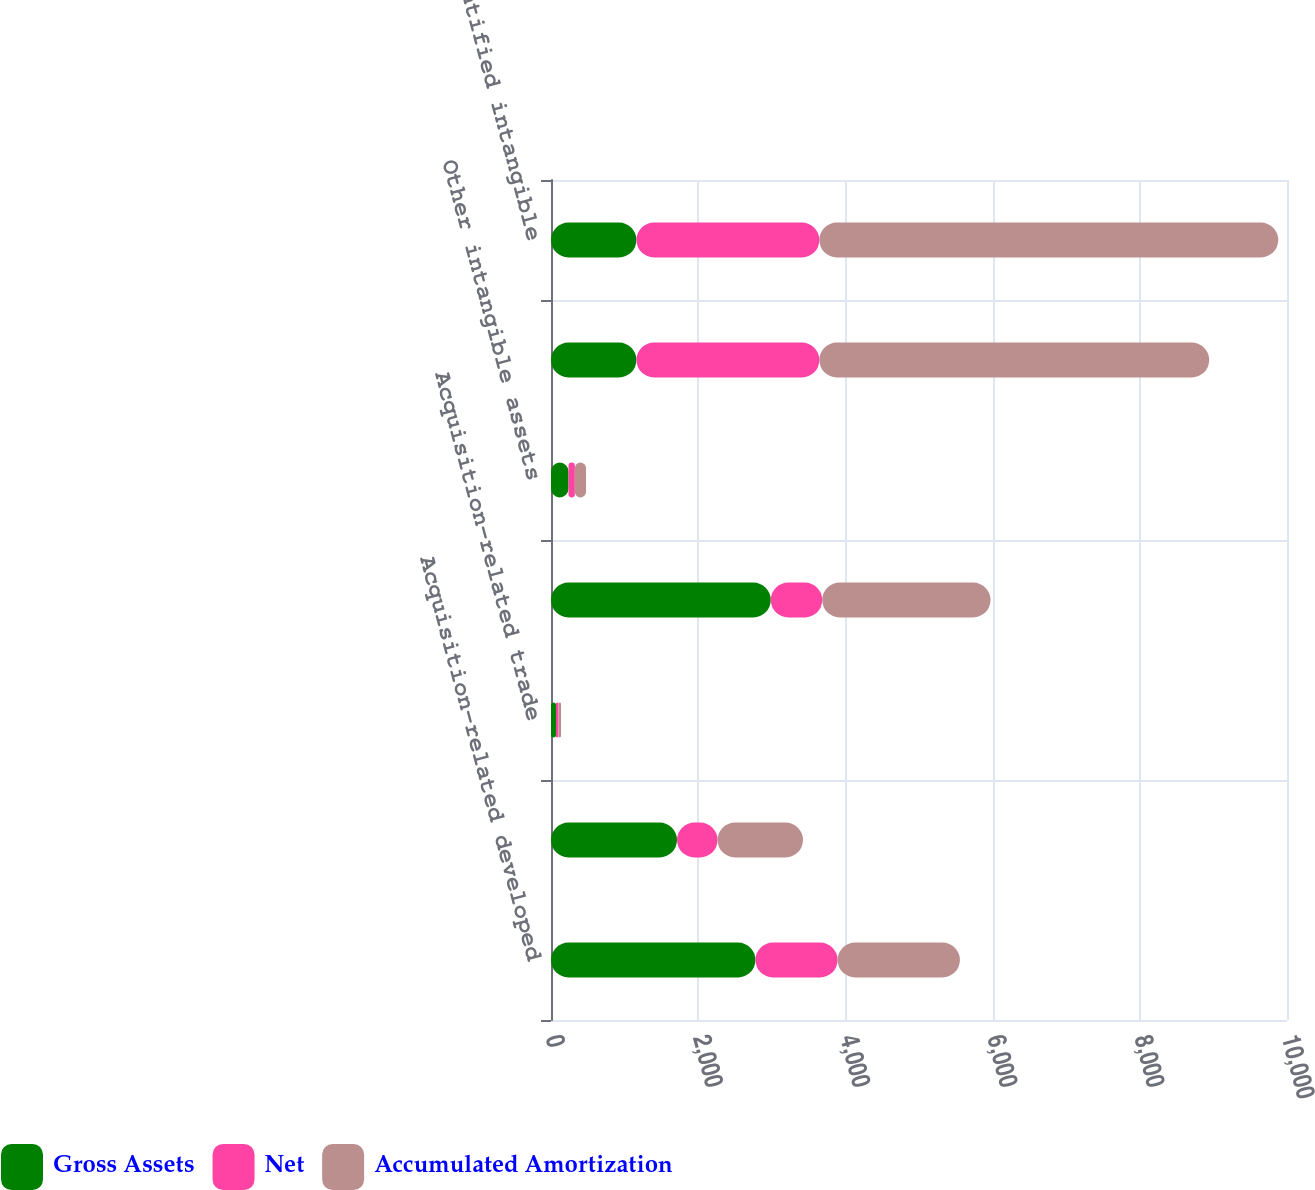Convert chart to OTSL. <chart><loc_0><loc_0><loc_500><loc_500><stacked_bar_chart><ecel><fcel>Acquisition-related developed<fcel>Acquisition-related customer<fcel>Acquisition-related trade<fcel>Licensed technology and<fcel>Other intangible assets<fcel>Identified intangible assets<fcel>Total identified intangible<nl><fcel>Gross Assets<fcel>2778<fcel>1712<fcel>68<fcel>2986<fcel>238<fcel>1161<fcel>1161<nl><fcel>Net<fcel>1116<fcel>551<fcel>33<fcel>699<fcel>86<fcel>2485<fcel>2485<nl><fcel>Accumulated Amortization<fcel>1662<fcel>1161<fcel>35<fcel>2287<fcel>152<fcel>5297<fcel>6235<nl></chart> 